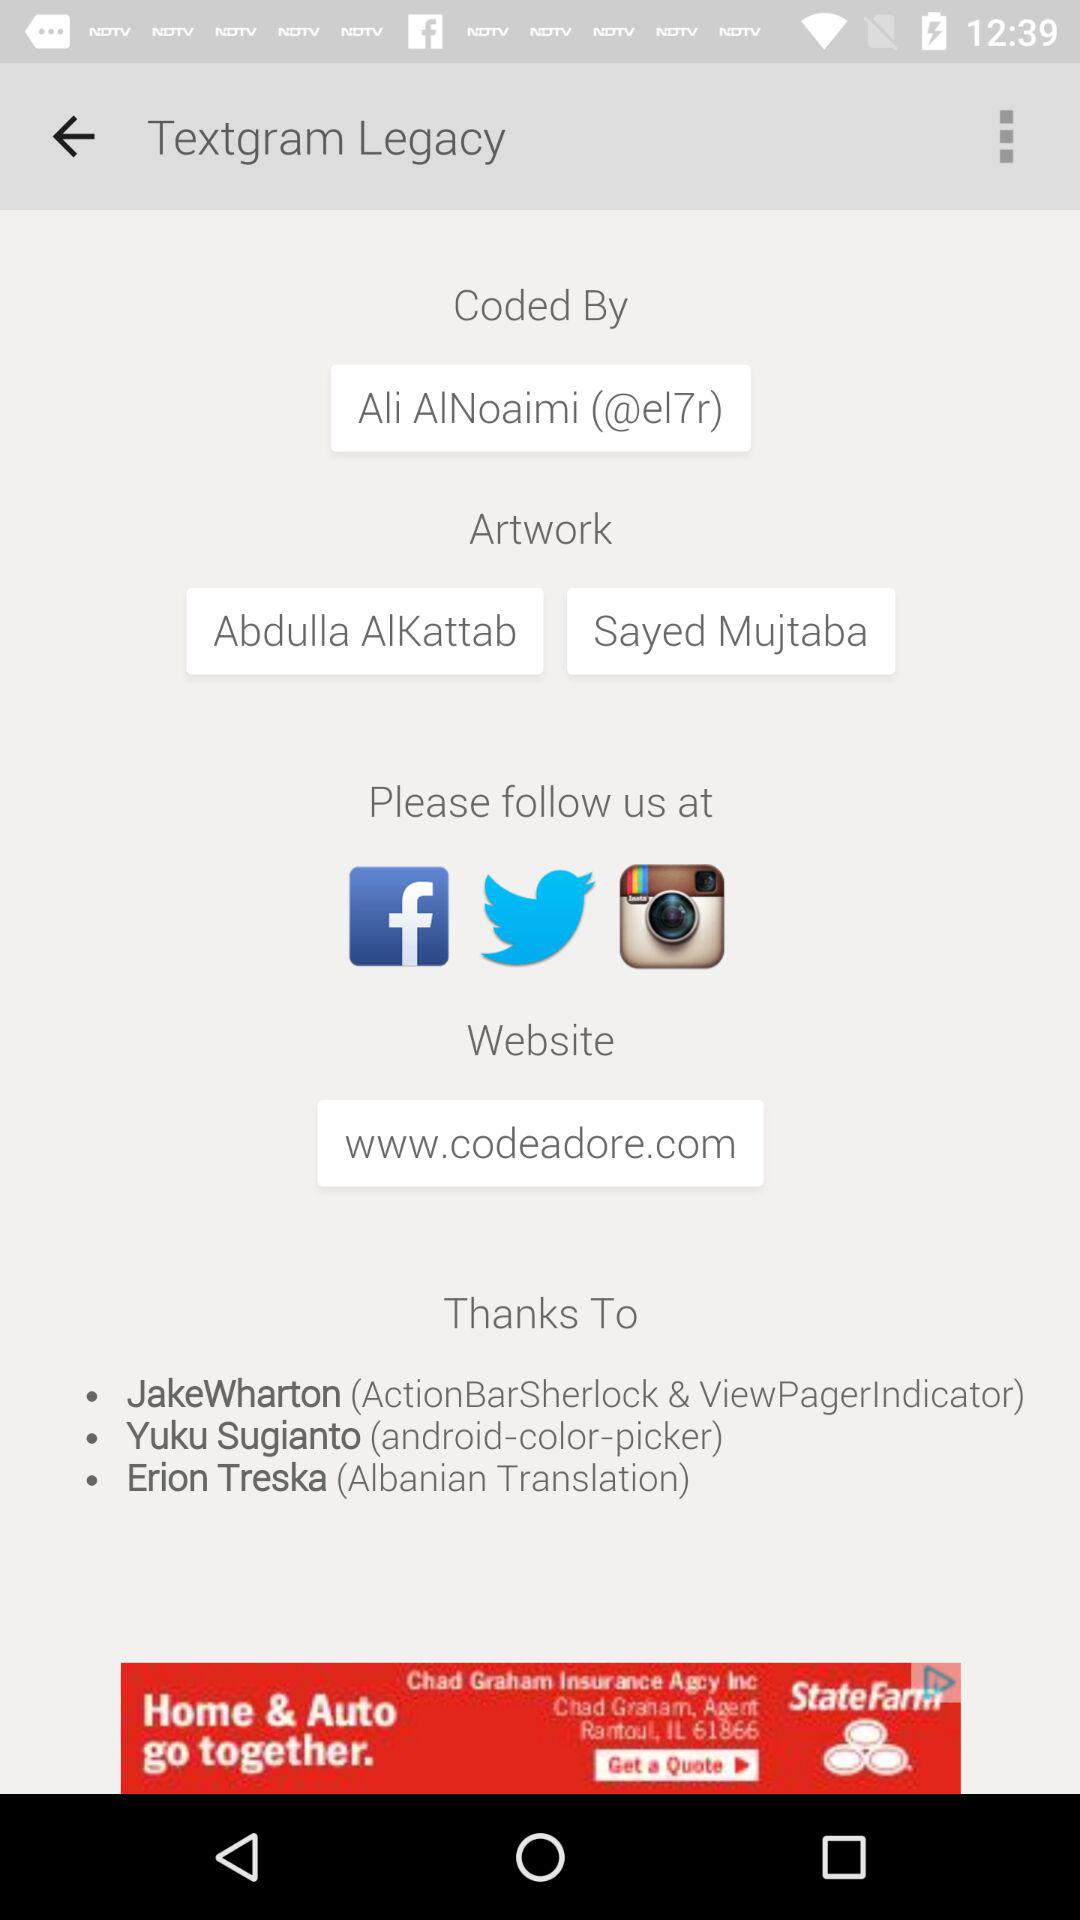Through which application can the user follow us? The user can follow us through the "Facebook", "Twitter" and "Instagram" applications. 